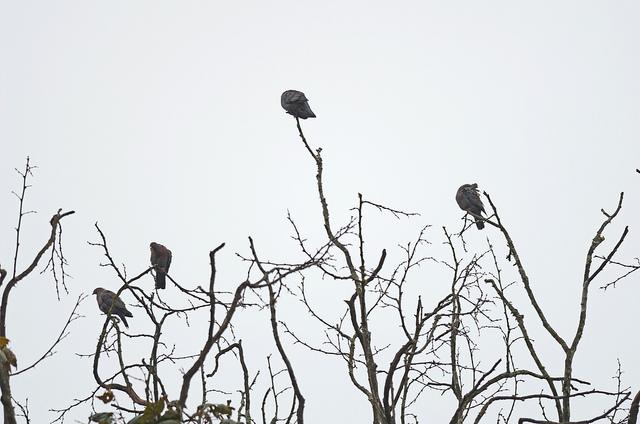How many birds are on the tree limbs?
Quick response, please. 4. What is in the tree?
Give a very brief answer. Birds. How many birds are in the picture?
Concise answer only. 4. How many birds are in the trees?
Be succinct. 4. How many birds are visible?
Short answer required. 4. Are the birds asleep?
Be succinct. No. What is the birds breast?
Be succinct. Unknown. What type of tree is in the picture?
Be succinct. Elm. 